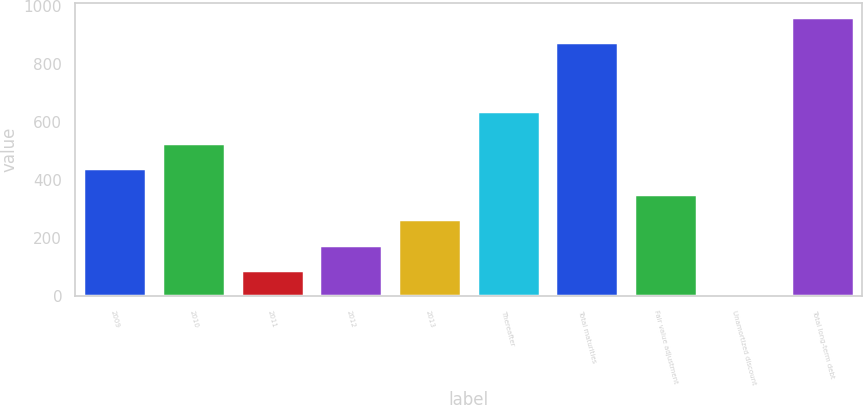Convert chart to OTSL. <chart><loc_0><loc_0><loc_500><loc_500><bar_chart><fcel>2009<fcel>2010<fcel>2011<fcel>2012<fcel>2013<fcel>Thereafter<fcel>Total maturities<fcel>Fair value adjustment<fcel>Unamortized discount<fcel>Total long-term debt<nl><fcel>442<fcel>530.2<fcel>89.2<fcel>177.4<fcel>265.6<fcel>639<fcel>875<fcel>353.8<fcel>1<fcel>963.2<nl></chart> 